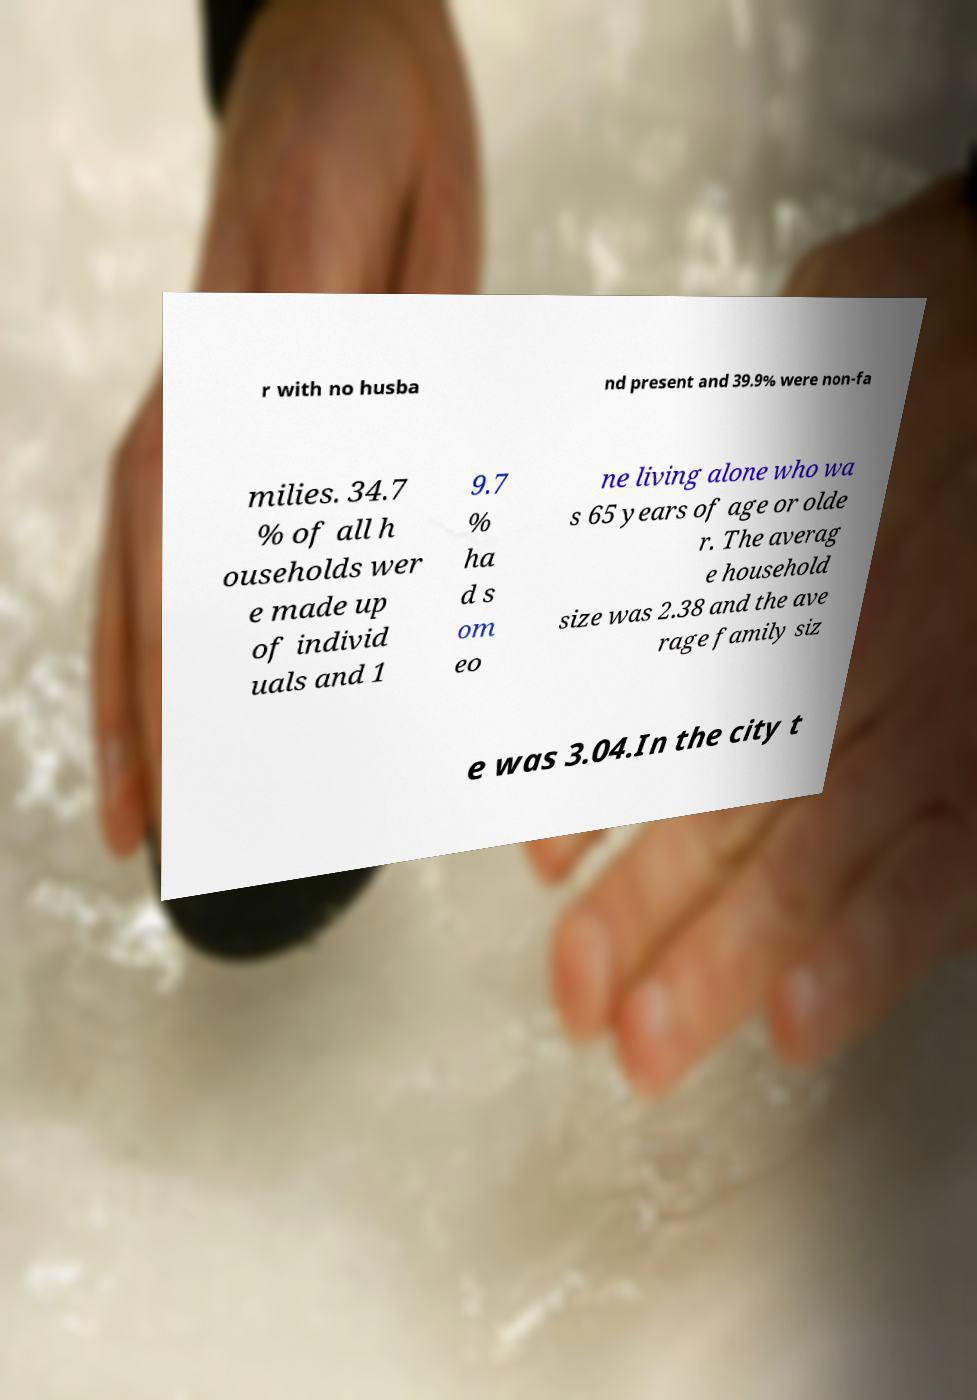Can you accurately transcribe the text from the provided image for me? r with no husba nd present and 39.9% were non-fa milies. 34.7 % of all h ouseholds wer e made up of individ uals and 1 9.7 % ha d s om eo ne living alone who wa s 65 years of age or olde r. The averag e household size was 2.38 and the ave rage family siz e was 3.04.In the city t 